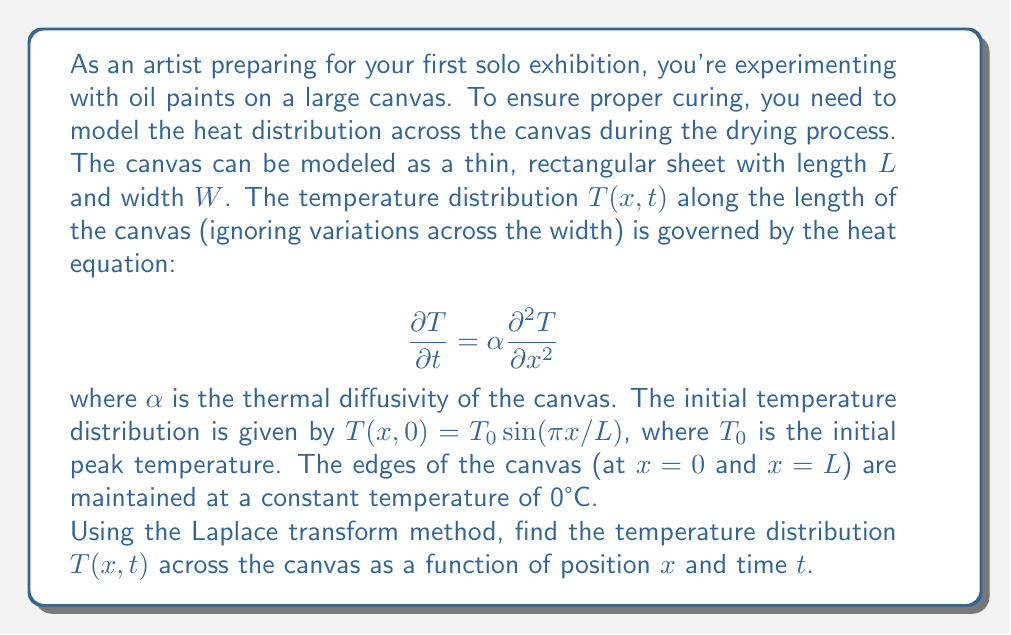Show me your answer to this math problem. To solve this problem using the Laplace transform method, we'll follow these steps:

1) Take the Laplace transform of the heat equation with respect to $t$:

   $$\mathcal{L}\left\{\frac{\partial T}{\partial t}\right\} = \alpha \mathcal{L}\left\{\frac{\partial^2 T}{\partial x^2}\right\}$$

   $$s\bar{T}(x,s) - T(x,0) = \alpha \frac{d^2\bar{T}}{dx^2}$$

   where $\bar{T}(x,s)$ is the Laplace transform of $T(x,t)$.

2) Substitute the initial condition:

   $$s\bar{T}(x,s) - T_0 \sin(\pi x/L) = \alpha \frac{d^2\bar{T}}{dx^2}$$

3) Rearrange the equation:

   $$\frac{d^2\bar{T}}{dx^2} - \frac{s}{\alpha}\bar{T} = -\frac{T_0}{\alpha} \sin(\pi x/L)$$

4) The general solution to this equation is:

   $$\bar{T}(x,s) = A \sinh(\sqrt{s/\alpha}x) + B \cosh(\sqrt{s/\alpha}x) + \frac{T_0 \sin(\pi x/L)}{s + \alpha(\pi/L)^2}$$

5) Apply the boundary conditions $\bar{T}(0,s) = \bar{T}(L,s) = 0$:

   At $x=0$: $B = 0$
   At $x=L$: $A \sinh(\sqrt{s/\alpha}L) + \frac{T_0 \sin(\pi)}{s + \alpha(\pi/L)^2} = 0$

   $A = -\frac{T_0}{s + \alpha(\pi/L)^2} \cdot \frac{\sin(\pi)}{\sinh(\sqrt{s/\alpha}L)} = 0$

6) Therefore, the solution in the Laplace domain is:

   $$\bar{T}(x,s) = \frac{T_0 \sin(\pi x/L)}{s + \alpha(\pi/L)^2}$$

7) Take the inverse Laplace transform:

   $$T(x,t) = T_0 \sin(\pi x/L) e^{-\alpha(\pi/L)^2 t}$$

This is the final solution for the temperature distribution across the canvas.
Answer: $T(x,t) = T_0 \sin(\pi x/L) e^{-\alpha(\pi/L)^2 t}$ 